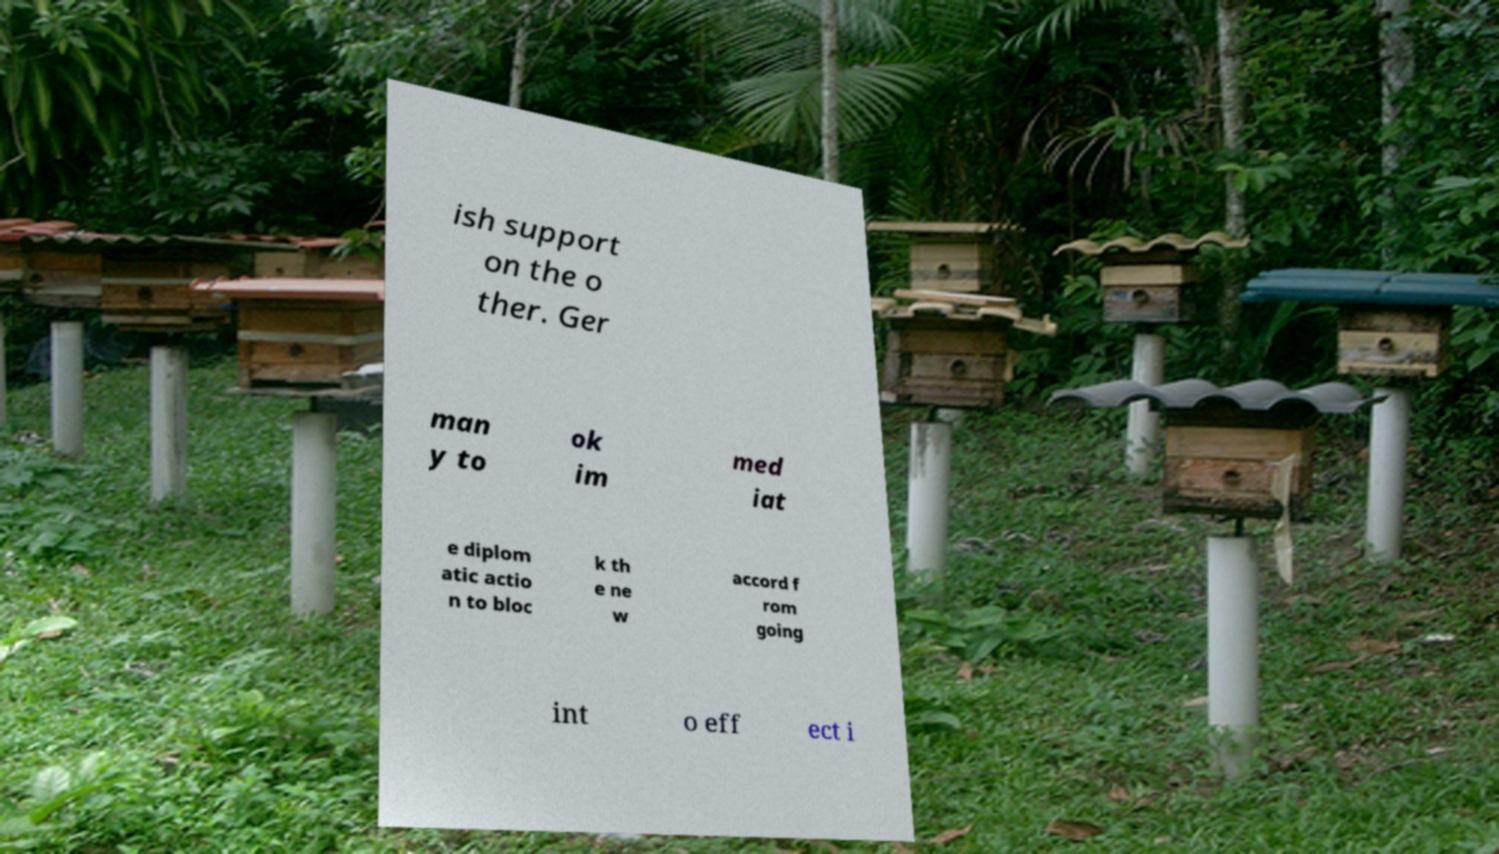Can you read and provide the text displayed in the image?This photo seems to have some interesting text. Can you extract and type it out for me? ish support on the o ther. Ger man y to ok im med iat e diplom atic actio n to bloc k th e ne w accord f rom going int o eff ect i 